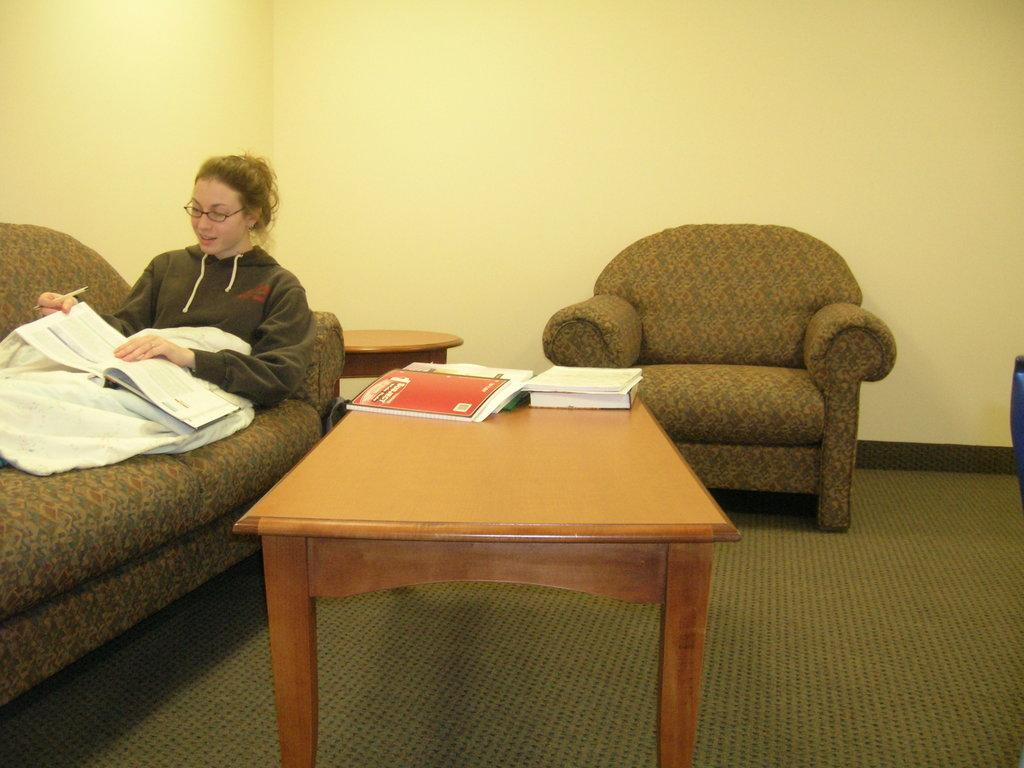What is the woman in the image doing? The woman is sitting on a sofa and reading a book. What is present on the wooden table in the image? Books are kept on the wooden table. Can you describe another piece of furniture in the image? There is another table in the corner of a wall. What is the taste of the crayon in the image? There is no crayon present in the image, so it is not possible to determine the taste of a crayon, as crayons are not edible and do not have a taste. Additionally, there is no crayon present in the image. 